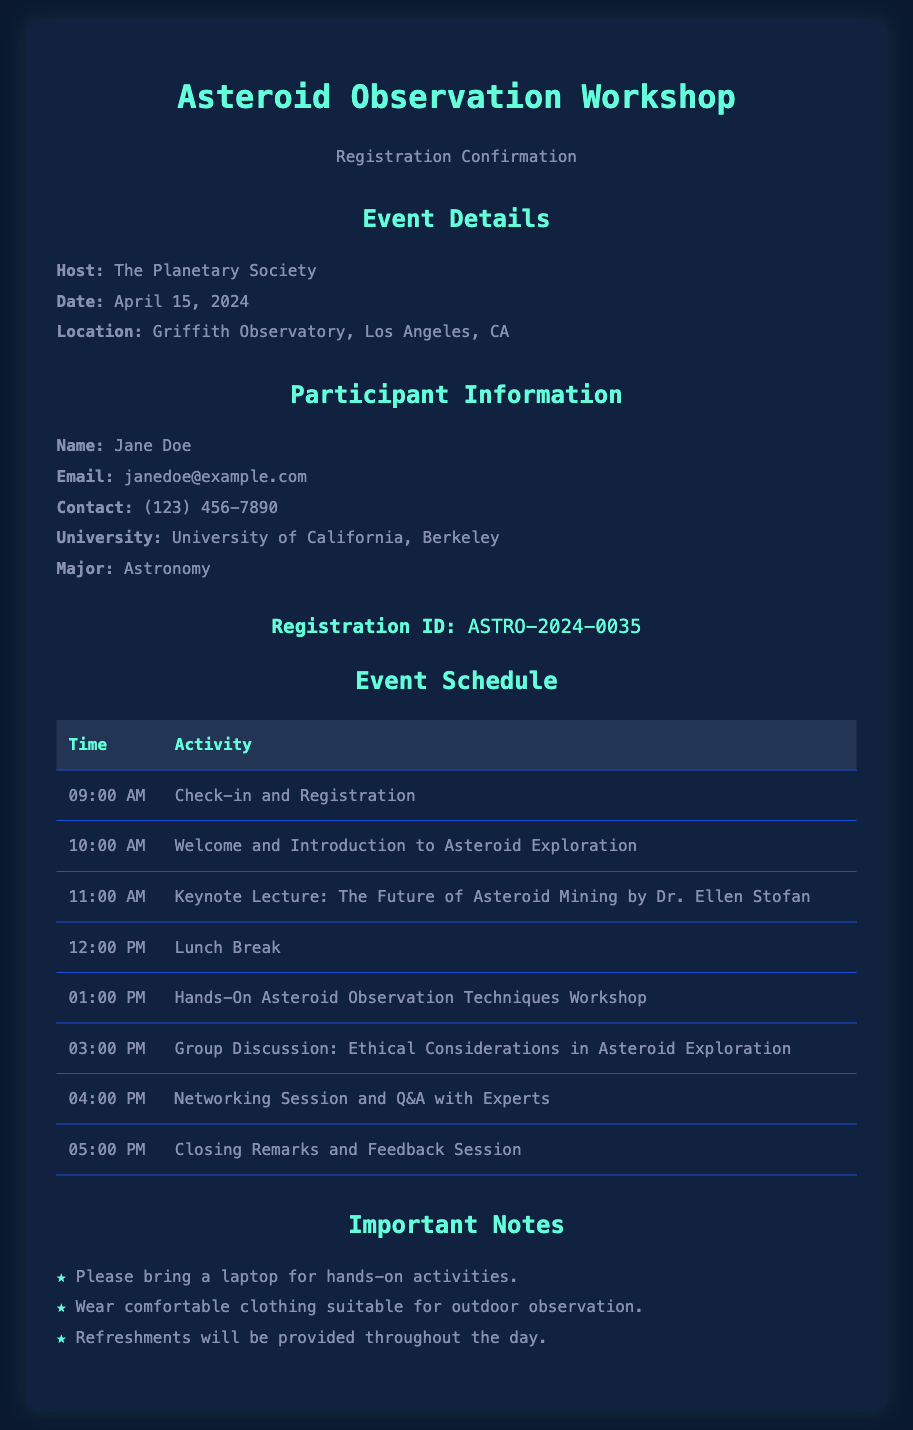What is the host of the workshop? The host is mentioned clearly in the document under the event details section.
Answer: The Planetary Society When is the workshop scheduled? The date of the workshop is specified explicitly in the document.
Answer: April 15, 2024 What is the registration ID? The registration ID is given in the participant information section, indicating unique identification for the registered participant.
Answer: ASTRO-2024-0035 Who is the keynote speaker? The document lists the keynote lecture along with the speaker's name in the event schedule section.
Answer: Dr. Ellen Stofan What activity starts at 01:00 PM? This requires cross-referencing the time with the activities listed in the event schedule.
Answer: Hands-On Asteroid Observation Techniques Workshop What should participants bring for the workshop? The important notes section specifies what participants need to bring.
Answer: A laptop How long is the lunch break? Based on the schedule, the timing of activities around the lunch break indicates its duration.
Answer: 1 hour Where will the workshop take place? The location is provided in an easily identifiable section of the document.
Answer: Griffith Observatory, Los Angeles, CA 